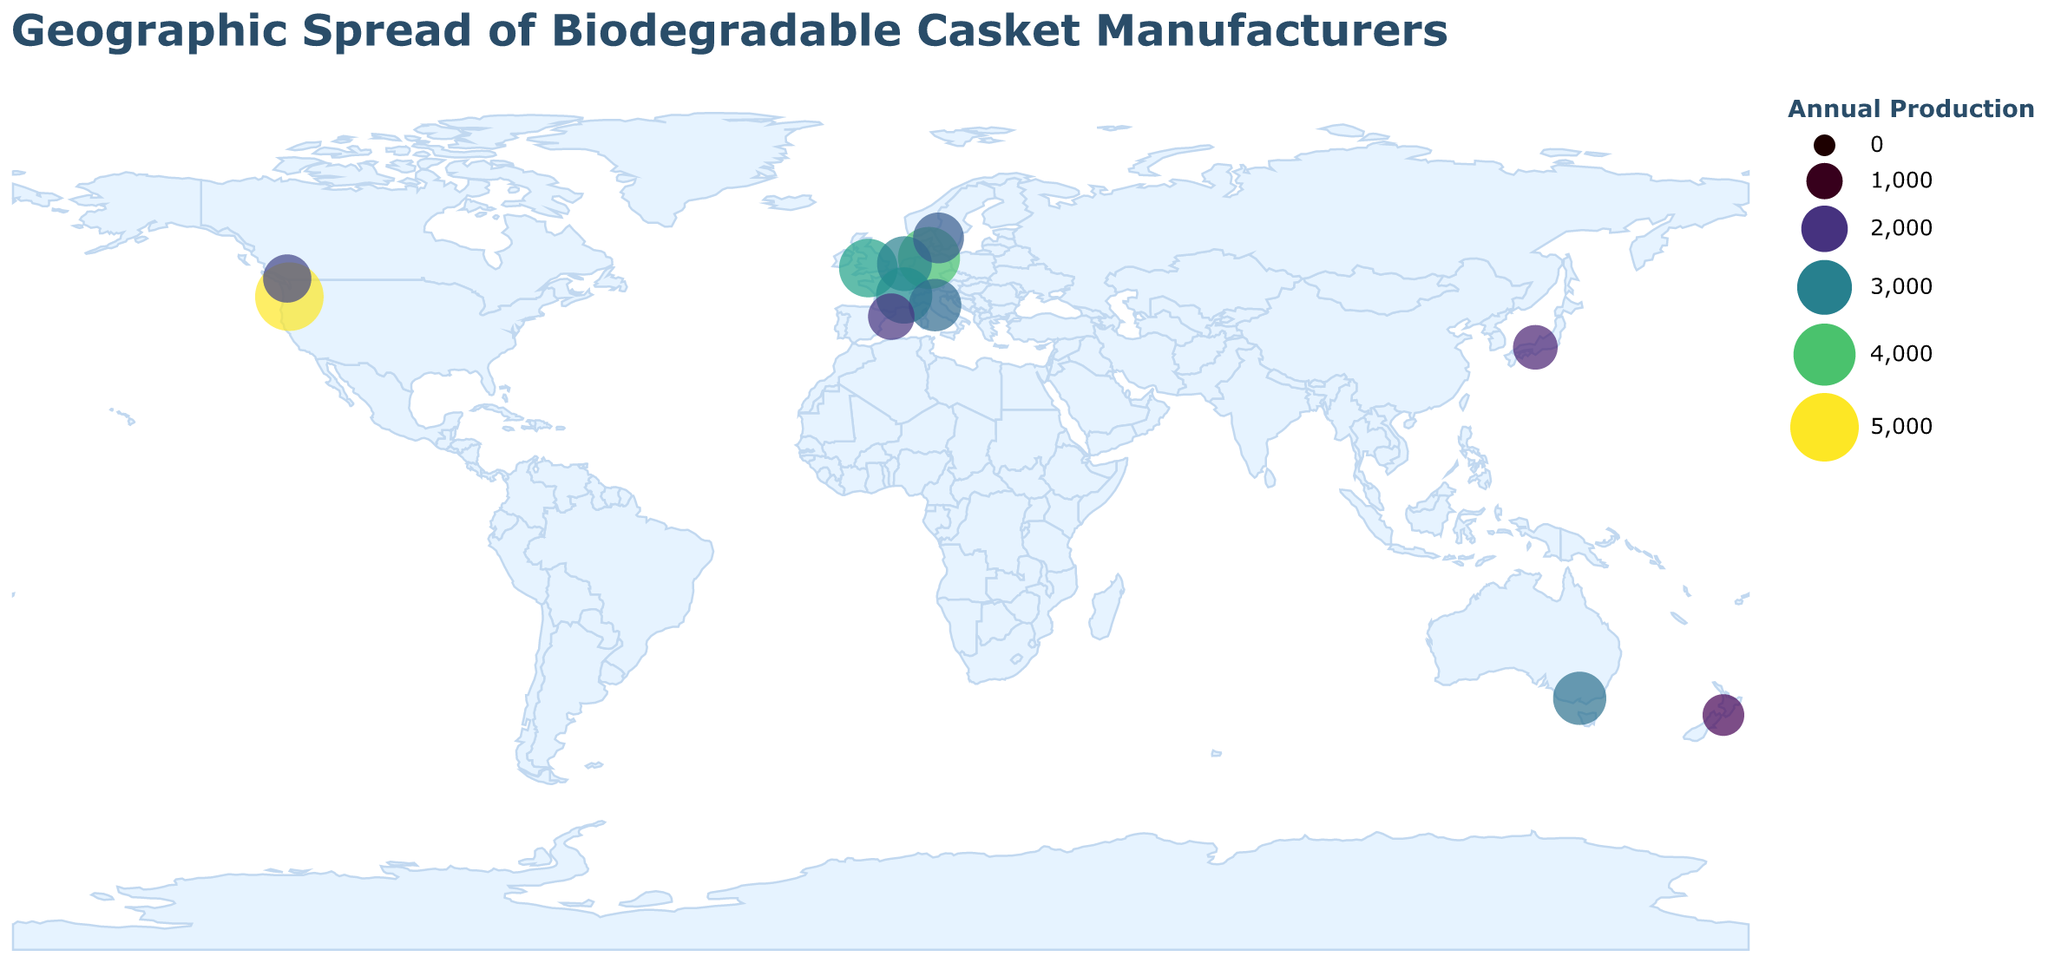Which city has the highest annual production of biodegradable caskets? Check for the city with the largest circle size, which represents the highest annual production. Portland has the largest circle.
Answer: Portland Which company in Europe has the largest production? Compare the European companies by looking at their circle sizes and color intensity. Cercueils Écologiques in Lyon has the largest size and most intense color.
Answer: Cercueils Écologiques How does the annual production of Bio-Sarg in Hamburg compare to that of Green Farewell in Bristol? Compare the circle sizes and color intensities of Hamburg and Bristol. Hamburg has a larger circle and deeper color, indicating higher production.
Answer: Bio-Sarg has higher production Which company in Asia has the lowest annual production? Locate the Asian companies on the map and compare their circle sizes. Shizen Coffins in Kyoto has the smallest circle.
Answer: Shizen Coffins What's the total annual production of all manufacturers represented in the figure? Sum the annual productions of all companies: 5000 (EcoCasket) + 3500 (Green Farewell) + 2800 (Nature's Rest) + 2200 (EarthReturn) + 4000 (Bio-Sarg) + 3000 (Eco Uitvaart) + 1800 (Shizen Coffins) + 2500 (Naturlig Kista) + 3200 (Cercueils Écologiques) + 2700 (Bare Biodegradabili) + 1500 (Kiwi EcoCoffins) + 2000 (Ataúdes Verdes) = 37200
Answer: 37200 Which continent has the most manufacturers of biodegradable caskets? Count the number of companies located in each continent. Europe has the most manufacturers.
Answer: Europe What is the average annual production of companies in Europe? Sum the productions of European companies and divide by their count: (3500 + 4000 + 3000 + 2500 + 3200 + 2700 + 2000) / 7 = 20900 / 7 = 2985.71
Answer: 2985.71 How does the production of EarthReturn in Vancouver compare to Kiwi EcoCoffins in Wellington? Compare the circle sizes of Vancouver and Wellington. Vancouver has a larger circle, indicating higher production.
Answer: EarthReturn has higher production 